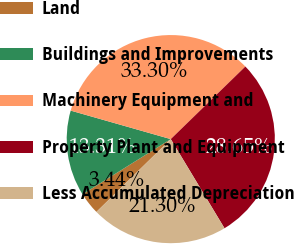Convert chart to OTSL. <chart><loc_0><loc_0><loc_500><loc_500><pie_chart><fcel>Land<fcel>Buildings and Improvements<fcel>Machinery Equipment and<fcel>Property Plant and Equipment<fcel>Less Accumulated Depreciation<nl><fcel>3.44%<fcel>13.31%<fcel>33.3%<fcel>28.65%<fcel>21.3%<nl></chart> 